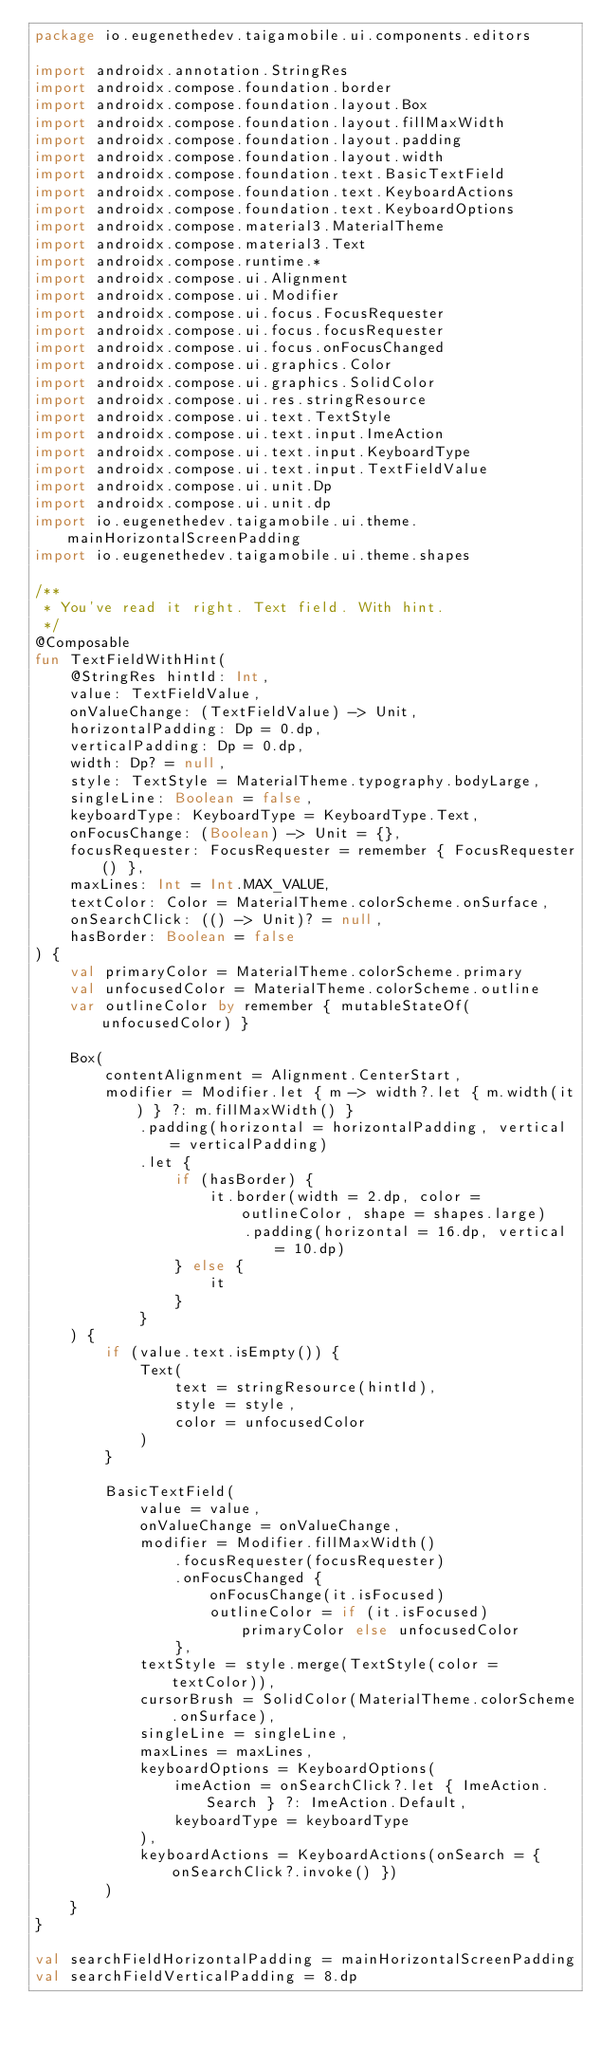<code> <loc_0><loc_0><loc_500><loc_500><_Kotlin_>package io.eugenethedev.taigamobile.ui.components.editors

import androidx.annotation.StringRes
import androidx.compose.foundation.border
import androidx.compose.foundation.layout.Box
import androidx.compose.foundation.layout.fillMaxWidth
import androidx.compose.foundation.layout.padding
import androidx.compose.foundation.layout.width
import androidx.compose.foundation.text.BasicTextField
import androidx.compose.foundation.text.KeyboardActions
import androidx.compose.foundation.text.KeyboardOptions
import androidx.compose.material3.MaterialTheme
import androidx.compose.material3.Text
import androidx.compose.runtime.*
import androidx.compose.ui.Alignment
import androidx.compose.ui.Modifier
import androidx.compose.ui.focus.FocusRequester
import androidx.compose.ui.focus.focusRequester
import androidx.compose.ui.focus.onFocusChanged
import androidx.compose.ui.graphics.Color
import androidx.compose.ui.graphics.SolidColor
import androidx.compose.ui.res.stringResource
import androidx.compose.ui.text.TextStyle
import androidx.compose.ui.text.input.ImeAction
import androidx.compose.ui.text.input.KeyboardType
import androidx.compose.ui.text.input.TextFieldValue
import androidx.compose.ui.unit.Dp
import androidx.compose.ui.unit.dp
import io.eugenethedev.taigamobile.ui.theme.mainHorizontalScreenPadding
import io.eugenethedev.taigamobile.ui.theme.shapes

/**
 * You've read it right. Text field. With hint.
 */
@Composable
fun TextFieldWithHint(
    @StringRes hintId: Int,
    value: TextFieldValue,
    onValueChange: (TextFieldValue) -> Unit,
    horizontalPadding: Dp = 0.dp,
    verticalPadding: Dp = 0.dp,
    width: Dp? = null,
    style: TextStyle = MaterialTheme.typography.bodyLarge,
    singleLine: Boolean = false,
    keyboardType: KeyboardType = KeyboardType.Text,
    onFocusChange: (Boolean) -> Unit = {},
    focusRequester: FocusRequester = remember { FocusRequester() },
    maxLines: Int = Int.MAX_VALUE,
    textColor: Color = MaterialTheme.colorScheme.onSurface,
    onSearchClick: (() -> Unit)? = null,
    hasBorder: Boolean = false
) {
    val primaryColor = MaterialTheme.colorScheme.primary
    val unfocusedColor = MaterialTheme.colorScheme.outline
    var outlineColor by remember { mutableStateOf(unfocusedColor) }

    Box(
        contentAlignment = Alignment.CenterStart,
        modifier = Modifier.let { m -> width?.let { m.width(it) } ?: m.fillMaxWidth() }
            .padding(horizontal = horizontalPadding, vertical = verticalPadding)
            .let {
                if (hasBorder) {
                    it.border(width = 2.dp, color = outlineColor, shape = shapes.large)
                        .padding(horizontal = 16.dp, vertical = 10.dp)
                } else {
                    it
                }
            }
    ) {
        if (value.text.isEmpty()) {
            Text(
                text = stringResource(hintId),
                style = style,
                color = unfocusedColor
            )
        }

        BasicTextField(
            value = value,
            onValueChange = onValueChange,
            modifier = Modifier.fillMaxWidth()
                .focusRequester(focusRequester)
                .onFocusChanged {
                    onFocusChange(it.isFocused)
                    outlineColor = if (it.isFocused) primaryColor else unfocusedColor
                },
            textStyle = style.merge(TextStyle(color = textColor)),
            cursorBrush = SolidColor(MaterialTheme.colorScheme.onSurface),
            singleLine = singleLine,
            maxLines = maxLines,
            keyboardOptions = KeyboardOptions(
                imeAction = onSearchClick?.let { ImeAction.Search } ?: ImeAction.Default,
                keyboardType = keyboardType
            ),
            keyboardActions = KeyboardActions(onSearch = { onSearchClick?.invoke() })
        )
    }
}

val searchFieldHorizontalPadding = mainHorizontalScreenPadding
val searchFieldVerticalPadding = 8.dp
</code> 